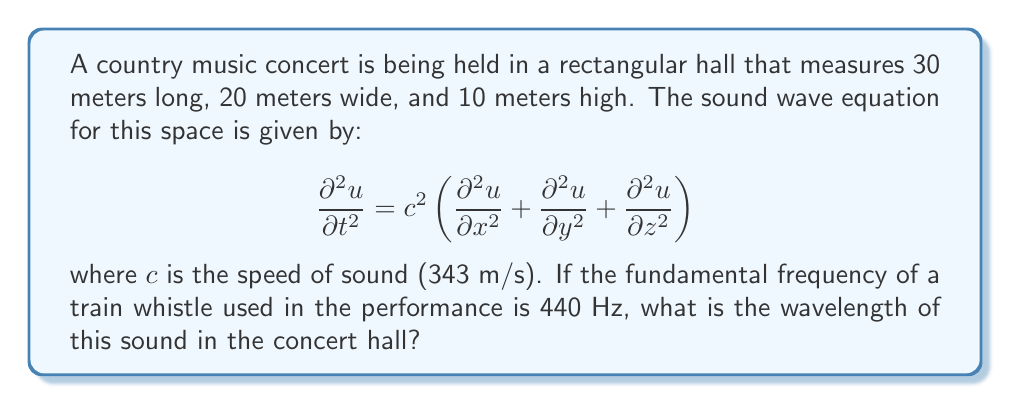Could you help me with this problem? To solve this problem, we'll follow these steps:

1) The wavelength $\lambda$ is related to the frequency $f$ and the speed of sound $c$ by the equation:

   $$c = f \lambda$$

2) We're given:
   - Speed of sound, $c = 343$ m/s
   - Frequency of the train whistle, $f = 440$ Hz

3) Rearranging the equation to solve for $\lambda$:

   $$\lambda = \frac{c}{f}$$

4) Substituting the known values:

   $$\lambda = \frac{343 \text{ m/s}}{440 \text{ Hz}}$$

5) Simplifying:

   $$\lambda = 0.77954545... \text{ m}$$

6) Rounding to three decimal places:

   $$\lambda \approx 0.780 \text{ m}$$

This wavelength is important for understanding how the sound will propagate in the concert hall. It's particularly relevant for analyzing standing waves and resonance, which can significantly affect the acoustics of the performance space.
Answer: 0.780 m 